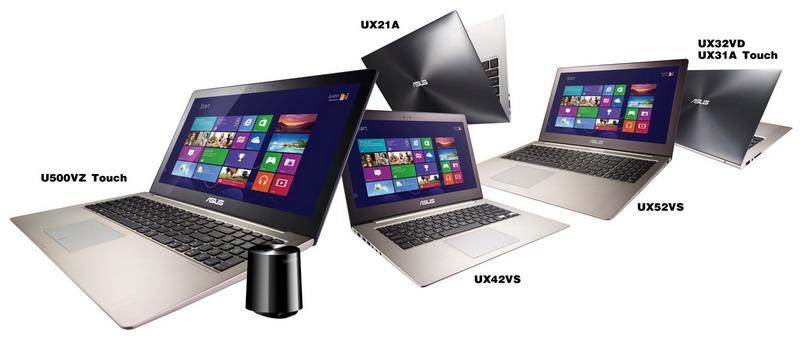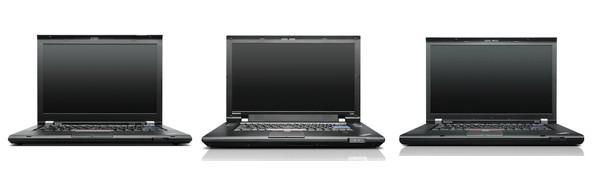The first image is the image on the left, the second image is the image on the right. Evaluate the accuracy of this statement regarding the images: "The right image contains exactly four laptop computers.". Is it true? Answer yes or no. No. The first image is the image on the left, the second image is the image on the right. Considering the images on both sides, is "There are more devices in the image on the left than in the image on the right." valid? Answer yes or no. Yes. 